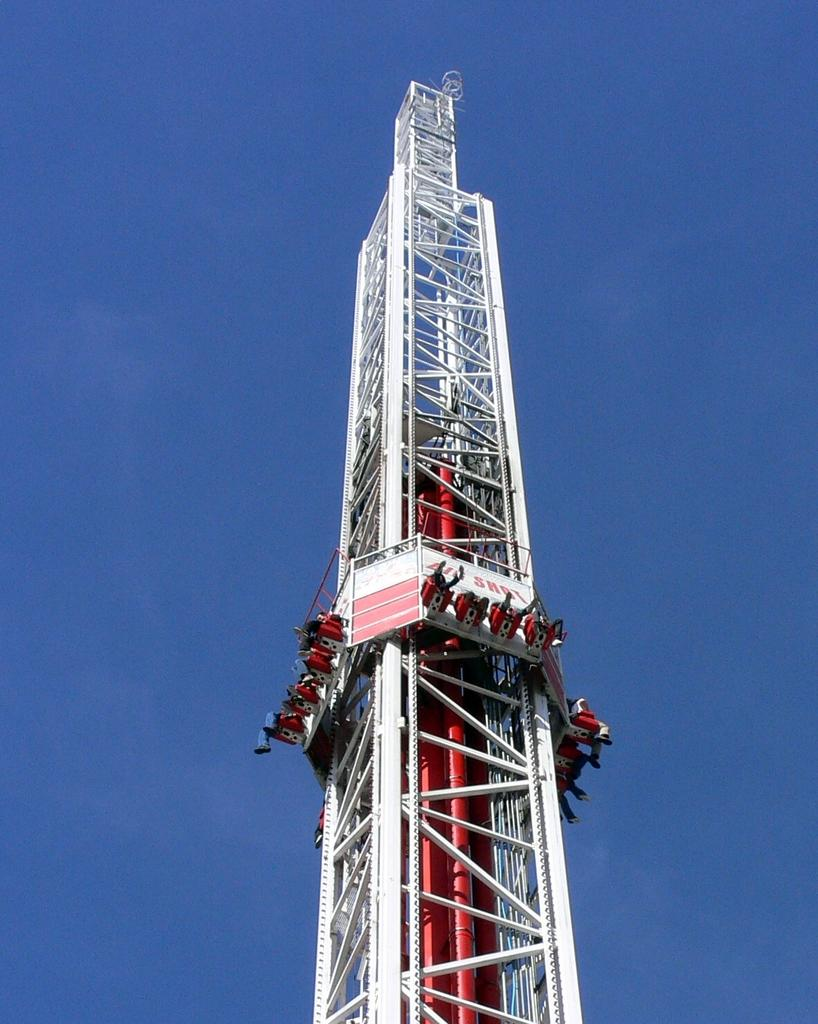What is the main subject of the picture? The main subject of the picture is a ride. What can be seen on the ride? People are visible on the ride. How is the ride designed? The ride resembles a tower. How many pies are being served on the ride? There is no mention of pies in the image, and they are not present. 